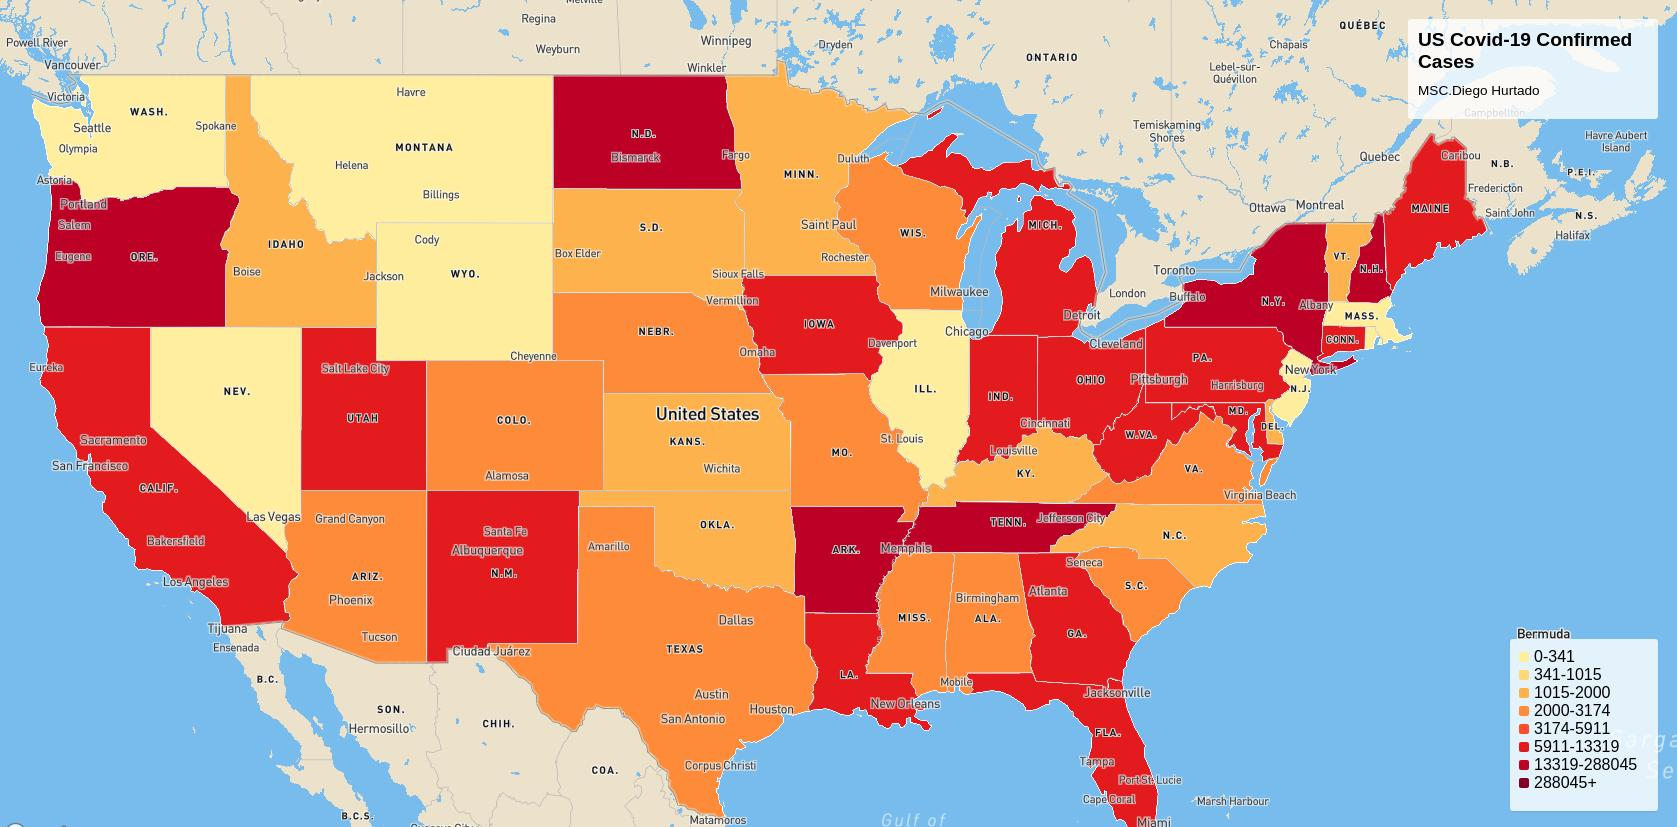Identify some key points in this picture. The range of confirmed cases of COVID-19 in Nevada is 0 to 341, as of February 16th, 2023. The range of confirmed cases of COVID-19 in Texas is from 2000 to 3174, as of February 18, 2023. The range of coronavirus cases in Washington is from 0 to 341, indicating that there have been no reported cases of the virus in the state. The range of coronavirus cases in Atlanta is from 3174 to 5911, indicating the variation in the number of cases reported in the city. The range of confirmed cases of coronavirus in Montana is 0 to 341 as of February 13, 2023. 